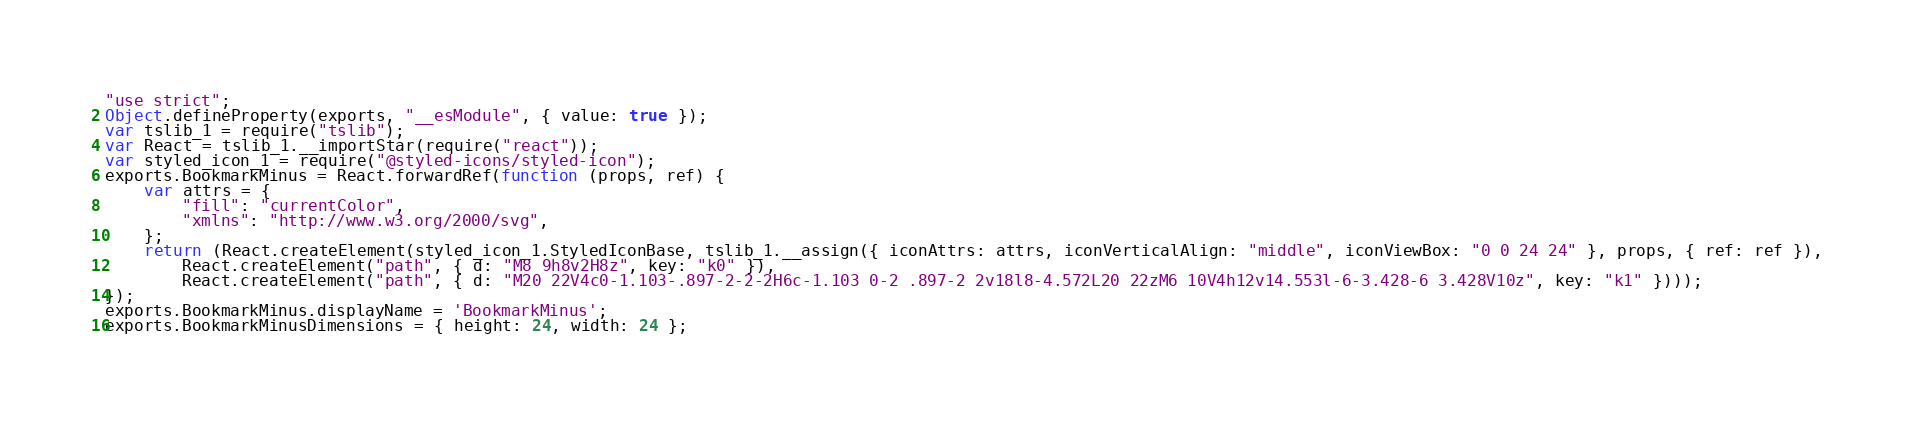<code> <loc_0><loc_0><loc_500><loc_500><_JavaScript_>"use strict";
Object.defineProperty(exports, "__esModule", { value: true });
var tslib_1 = require("tslib");
var React = tslib_1.__importStar(require("react"));
var styled_icon_1 = require("@styled-icons/styled-icon");
exports.BookmarkMinus = React.forwardRef(function (props, ref) {
    var attrs = {
        "fill": "currentColor",
        "xmlns": "http://www.w3.org/2000/svg",
    };
    return (React.createElement(styled_icon_1.StyledIconBase, tslib_1.__assign({ iconAttrs: attrs, iconVerticalAlign: "middle", iconViewBox: "0 0 24 24" }, props, { ref: ref }),
        React.createElement("path", { d: "M8 9h8v2H8z", key: "k0" }),
        React.createElement("path", { d: "M20 22V4c0-1.103-.897-2-2-2H6c-1.103 0-2 .897-2 2v18l8-4.572L20 22zM6 10V4h12v14.553l-6-3.428-6 3.428V10z", key: "k1" })));
});
exports.BookmarkMinus.displayName = 'BookmarkMinus';
exports.BookmarkMinusDimensions = { height: 24, width: 24 };
</code> 